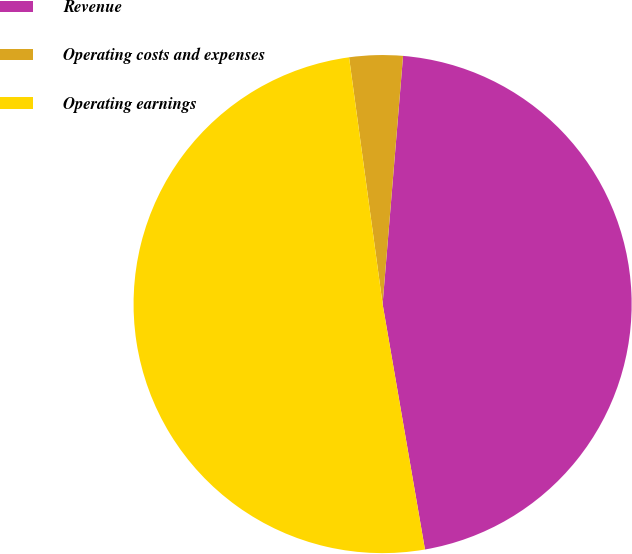Convert chart. <chart><loc_0><loc_0><loc_500><loc_500><pie_chart><fcel>Revenue<fcel>Operating costs and expenses<fcel>Operating earnings<nl><fcel>45.97%<fcel>3.46%<fcel>50.57%<nl></chart> 